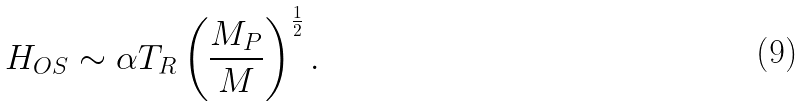Convert formula to latex. <formula><loc_0><loc_0><loc_500><loc_500>H _ { O S } \sim \alpha T _ { R } \left ( \frac { M _ { P } } { M } \right ) ^ { \frac { 1 } { 2 } } .</formula> 